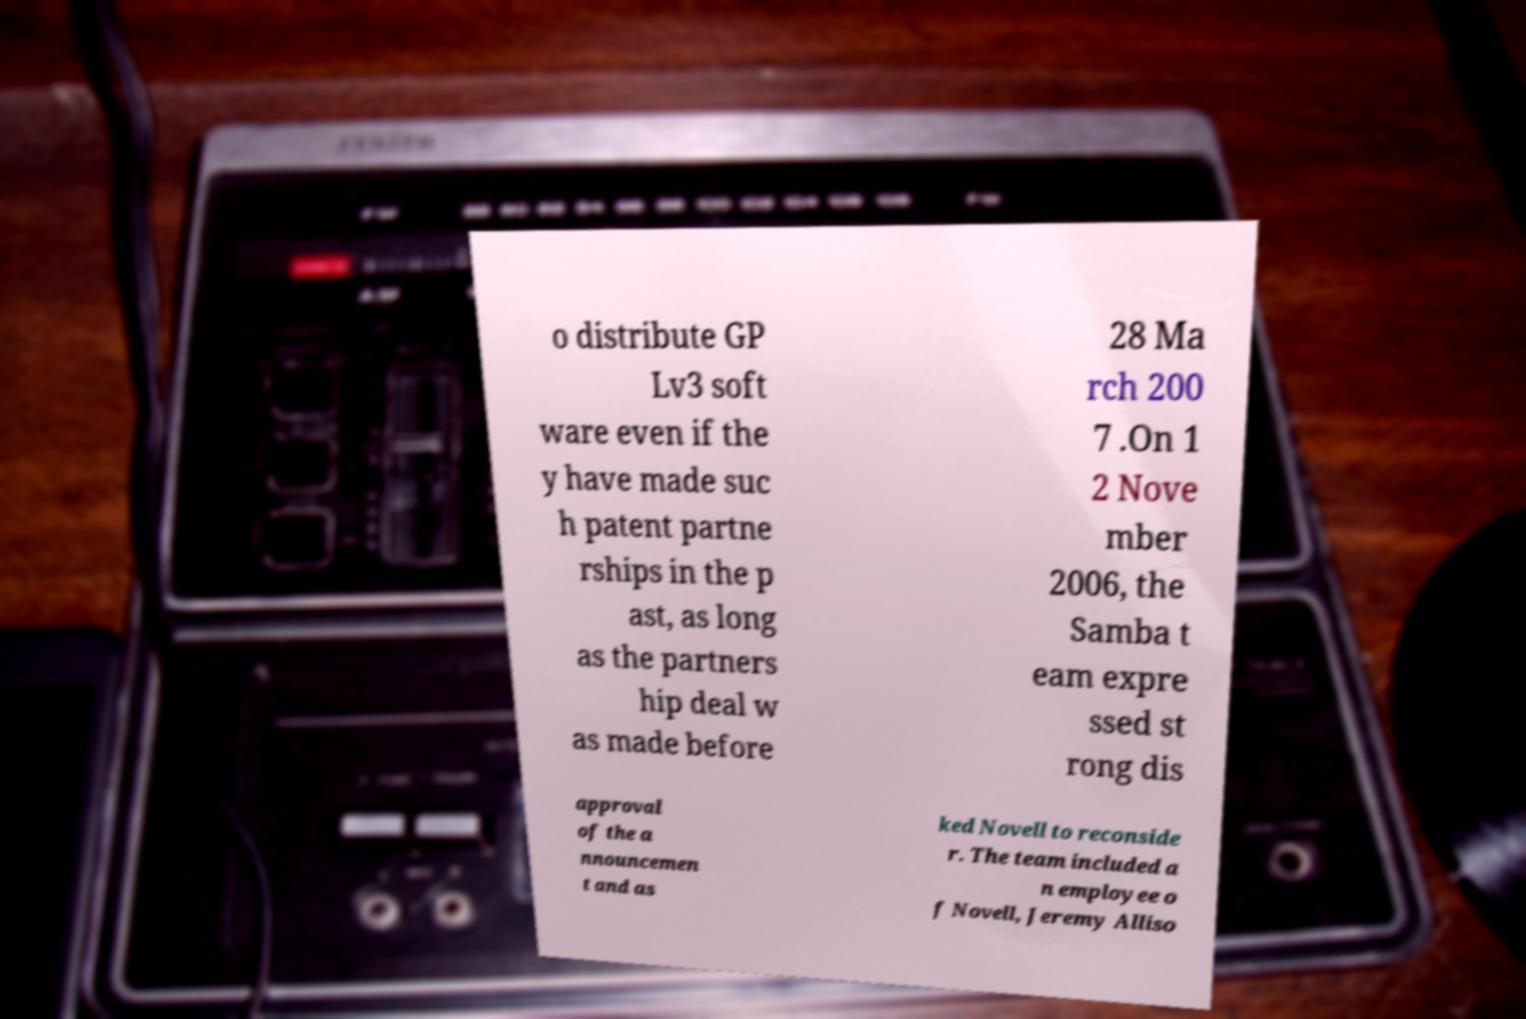Could you extract and type out the text from this image? o distribute GP Lv3 soft ware even if the y have made suc h patent partne rships in the p ast, as long as the partners hip deal w as made before 28 Ma rch 200 7 .On 1 2 Nove mber 2006, the Samba t eam expre ssed st rong dis approval of the a nnouncemen t and as ked Novell to reconside r. The team included a n employee o f Novell, Jeremy Alliso 